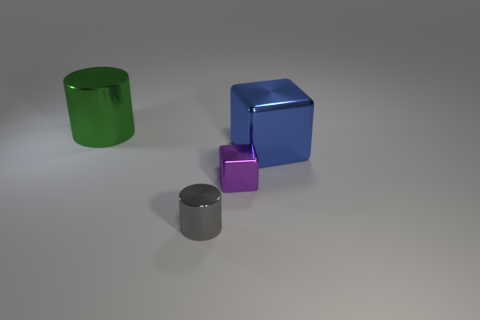Add 1 small blue objects. How many objects exist? 5 Add 3 large green things. How many large green things exist? 4 Subtract 0 yellow blocks. How many objects are left? 4 Subtract all green matte cylinders. Subtract all gray metallic things. How many objects are left? 3 Add 2 tiny cubes. How many tiny cubes are left? 3 